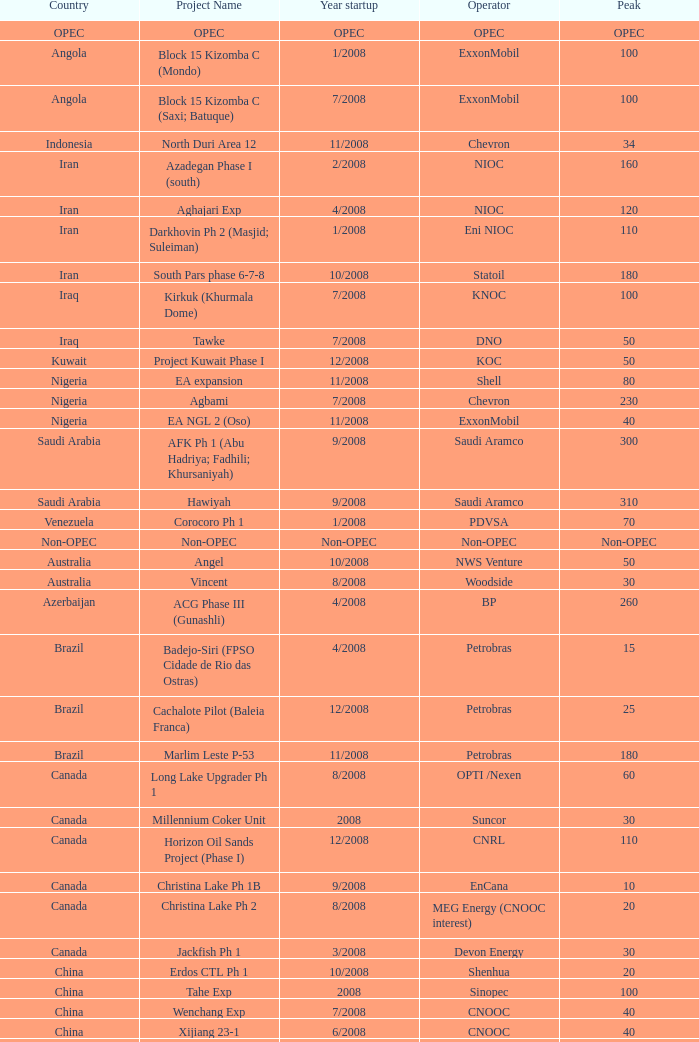Could you parse the entire table as a dict? {'header': ['Country', 'Project Name', 'Year startup', 'Operator', 'Peak'], 'rows': [['OPEC', 'OPEC', 'OPEC', 'OPEC', 'OPEC'], ['Angola', 'Block 15 Kizomba C (Mondo)', '1/2008', 'ExxonMobil', '100'], ['Angola', 'Block 15 Kizomba C (Saxi; Batuque)', '7/2008', 'ExxonMobil', '100'], ['Indonesia', 'North Duri Area 12', '11/2008', 'Chevron', '34'], ['Iran', 'Azadegan Phase I (south)', '2/2008', 'NIOC', '160'], ['Iran', 'Aghajari Exp', '4/2008', 'NIOC', '120'], ['Iran', 'Darkhovin Ph 2 (Masjid; Suleiman)', '1/2008', 'Eni NIOC', '110'], ['Iran', 'South Pars phase 6-7-8', '10/2008', 'Statoil', '180'], ['Iraq', 'Kirkuk (Khurmala Dome)', '7/2008', 'KNOC', '100'], ['Iraq', 'Tawke', '7/2008', 'DNO', '50'], ['Kuwait', 'Project Kuwait Phase I', '12/2008', 'KOC', '50'], ['Nigeria', 'EA expansion', '11/2008', 'Shell', '80'], ['Nigeria', 'Agbami', '7/2008', 'Chevron', '230'], ['Nigeria', 'EA NGL 2 (Oso)', '11/2008', 'ExxonMobil', '40'], ['Saudi Arabia', 'AFK Ph 1 (Abu Hadriya; Fadhili; Khursaniyah)', '9/2008', 'Saudi Aramco', '300'], ['Saudi Arabia', 'Hawiyah', '9/2008', 'Saudi Aramco', '310'], ['Venezuela', 'Corocoro Ph 1', '1/2008', 'PDVSA', '70'], ['Non-OPEC', 'Non-OPEC', 'Non-OPEC', 'Non-OPEC', 'Non-OPEC'], ['Australia', 'Angel', '10/2008', 'NWS Venture', '50'], ['Australia', 'Vincent', '8/2008', 'Woodside', '30'], ['Azerbaijan', 'ACG Phase III (Gunashli)', '4/2008', 'BP', '260'], ['Brazil', 'Badejo-Siri (FPSO Cidade de Rio das Ostras)', '4/2008', 'Petrobras', '15'], ['Brazil', 'Cachalote Pilot (Baleia Franca)', '12/2008', 'Petrobras', '25'], ['Brazil', 'Marlim Leste P-53', '11/2008', 'Petrobras', '180'], ['Canada', 'Long Lake Upgrader Ph 1', '8/2008', 'OPTI /Nexen', '60'], ['Canada', 'Millennium Coker Unit', '2008', 'Suncor', '30'], ['Canada', 'Horizon Oil Sands Project (Phase I)', '12/2008', 'CNRL', '110'], ['Canada', 'Christina Lake Ph 1B', '9/2008', 'EnCana', '10'], ['Canada', 'Christina Lake Ph 2', '8/2008', 'MEG Energy (CNOOC interest)', '20'], ['Canada', 'Jackfish Ph 1', '3/2008', 'Devon Energy', '30'], ['China', 'Erdos CTL Ph 1', '10/2008', 'Shenhua', '20'], ['China', 'Tahe Exp', '2008', 'Sinopec', '100'], ['China', 'Wenchang Exp', '7/2008', 'CNOOC', '40'], ['China', 'Xijiang 23-1', '6/2008', 'CNOOC', '40'], ['Congo', 'Moho Bilondo', '4/2008', 'Total', '90'], ['Egypt', 'Saqqara', '3/2008', 'BP', '40'], ['India', 'MA field (KG-D6)', '9/2008', 'Reliance', '40'], ['Kazakhstan', 'Dunga', '3/2008', 'Maersk', '150'], ['Kazakhstan', 'Komsomolskoe', '5/2008', 'Petrom', '10'], ['Mexico', '( Chicontepec ) Exp 1', '2008', 'PEMEX', '200'], ['Mexico', 'Antonio J Bermudez Exp', '5/2008', 'PEMEX', '20'], ['Mexico', 'Bellota Chinchorro Exp', '5/2008', 'PEMEX', '20'], ['Mexico', 'Ixtal Manik', '2008', 'PEMEX', '55'], ['Mexico', 'Jujo Tecominoacan Exp', '2008', 'PEMEX', '15'], ['Norway', 'Alvheim; Volund; Vilje', '6/2008', 'Marathon', '100'], ['Norway', 'Volve', '2/2008', 'StatoilHydro', '35'], ['Oman', 'Mukhaizna EOR Ph 1', '2008', 'Occidental', '40'], ['Philippines', 'Galoc', '10/2008', 'GPC', '15'], ['Russia', 'Talakan Ph 1', '10/2008', 'Surgutneftegaz', '60'], ['Russia', 'Verkhnechonsk Ph 1 (early oil)', '10/2008', 'TNK-BP Rosneft', '20'], ['Russia', 'Yuzhno-Khylchuyuskoye "YK" Ph 1', '8/2008', 'Lukoil ConocoPhillips', '75'], ['Thailand', 'Bualuang', '8/2008', 'Salamander', '10'], ['UK', 'Britannia Satellites (Callanish; Brodgar)', '7/2008', 'Conoco Phillips', '25'], ['USA', 'Blind Faith', '11/2008', 'Chevron', '45'], ['USA', 'Neptune', '7/2008', 'BHP Billiton', '25'], ['USA', 'Oooguruk', '6/2008', 'Pioneer', '15'], ['USA', 'Qannik', '7/2008', 'ConocoPhillips', '4'], ['USA', 'Thunder Horse', '6/2008', 'BP', '210'], ['USA', 'Ursa Princess Exp', '1/2008', 'Shell', '30'], ['Vietnam', 'Ca Ngu Vang (Golden Tuna)', '7/2008', 'HVJOC', '15'], ['Vietnam', 'Su Tu Vang', '10/2008', 'Cuu Long Joint', '40'], ['Vietnam', 'Song Doc', '12/2008', 'Talisman', '10']]} What is the project designation related to a country in opec? OPEC. 